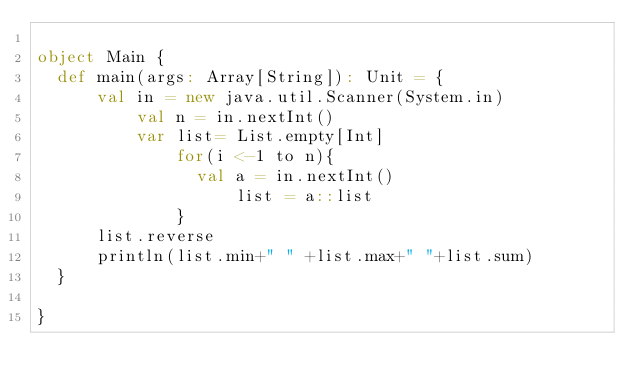Convert code to text. <code><loc_0><loc_0><loc_500><loc_500><_Scala_>
object Main {
	def main(args: Array[String]): Unit = {
			val in = new java.util.Scanner(System.in)
					val n = in.nextInt()
					var list= List.empty[Int] 
							for(i <-1 to n){
								val a = in.nextInt()
										list = a::list
							}
			list.reverse
			println(list.min+" " +list.max+" "+list.sum)   
	}

}</code> 